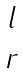<formula> <loc_0><loc_0><loc_500><loc_500>\begin{matrix} l \\ r \end{matrix}</formula> 